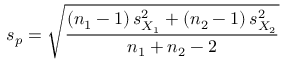Convert formula to latex. <formula><loc_0><loc_0><loc_500><loc_500>s _ { p } = { \sqrt { \frac { \left ( n _ { 1 } - 1 \right ) s _ { X _ { 1 } } ^ { 2 } + \left ( n _ { 2 } - 1 \right ) s _ { X _ { 2 } } ^ { 2 } } { n _ { 1 } + n _ { 2 } - 2 } } }</formula> 